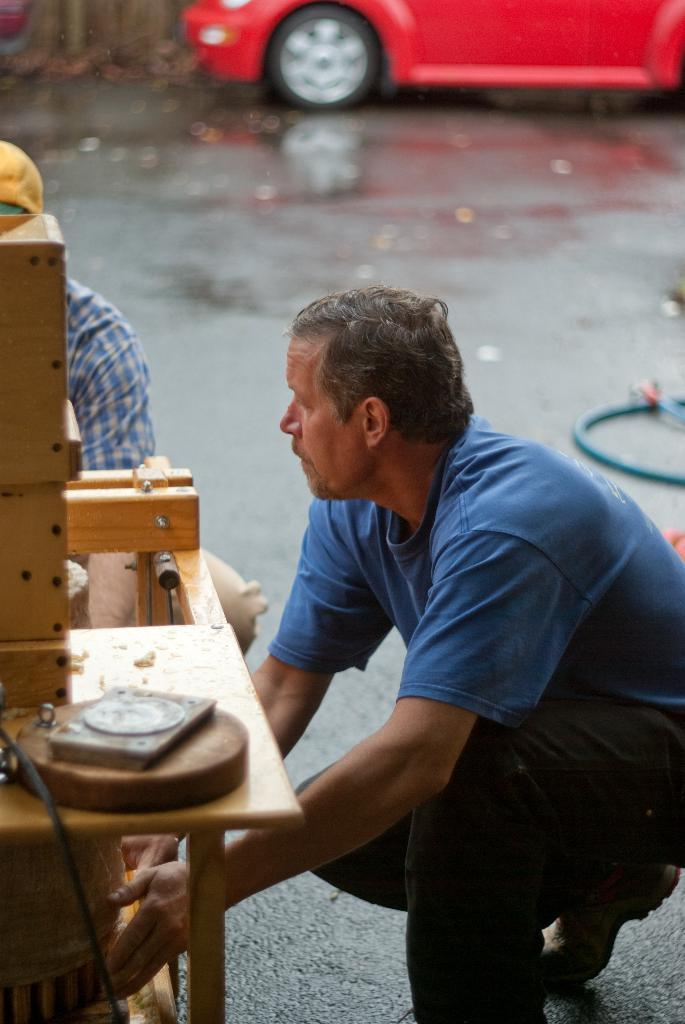Who is present in the image? There is a man in the image. Where is the man located in the image? The man is on the right side of the image. What is the man wearing in the image? The man is wearing a blue t-shirt. What can be seen in the background of the image? There is a road in the image. What type of vehicle is present in the image? There is a red car in the image. What type of grape is the man holding in the image? There is no grape present in the image; the man is wearing a blue t-shirt and there is a red car in the image. 